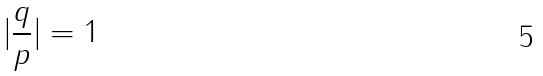Convert formula to latex. <formula><loc_0><loc_0><loc_500><loc_500>| \frac { q } { p } | = 1</formula> 